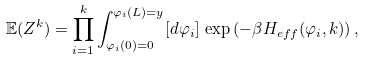Convert formula to latex. <formula><loc_0><loc_0><loc_500><loc_500>\mathbb { E } ( Z ^ { k } ) = \prod _ { i = 1 } ^ { k } \int _ { \varphi _ { i } ( 0 ) = 0 } ^ { \varphi _ { i } ( L ) = y } [ d \varphi _ { i } ] \, \exp \left ( - \beta H _ { e f f } ( \varphi _ { i } , k ) \right ) ,</formula> 